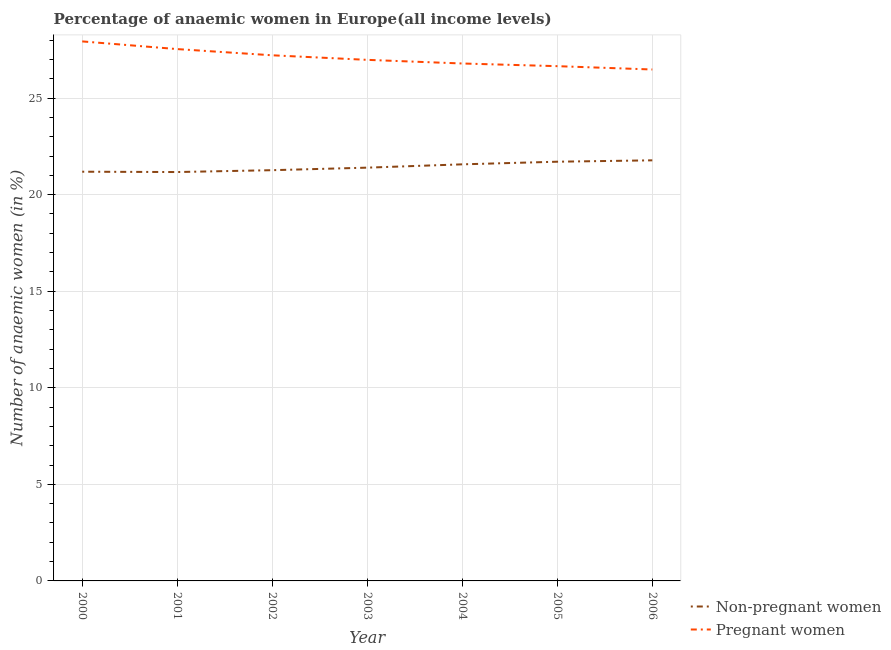How many different coloured lines are there?
Offer a terse response. 2. What is the percentage of non-pregnant anaemic women in 2002?
Make the answer very short. 21.27. Across all years, what is the maximum percentage of pregnant anaemic women?
Keep it short and to the point. 27.93. Across all years, what is the minimum percentage of pregnant anaemic women?
Keep it short and to the point. 26.48. What is the total percentage of non-pregnant anaemic women in the graph?
Make the answer very short. 150.07. What is the difference between the percentage of pregnant anaemic women in 2002 and that in 2006?
Your response must be concise. 0.74. What is the difference between the percentage of pregnant anaemic women in 2003 and the percentage of non-pregnant anaemic women in 2005?
Ensure brevity in your answer.  5.27. What is the average percentage of pregnant anaemic women per year?
Your response must be concise. 27.08. In the year 2002, what is the difference between the percentage of non-pregnant anaemic women and percentage of pregnant anaemic women?
Offer a terse response. -5.95. In how many years, is the percentage of non-pregnant anaemic women greater than 25 %?
Give a very brief answer. 0. What is the ratio of the percentage of pregnant anaemic women in 2001 to that in 2006?
Offer a very short reply. 1.04. Is the percentage of non-pregnant anaemic women in 2003 less than that in 2004?
Offer a terse response. Yes. What is the difference between the highest and the second highest percentage of non-pregnant anaemic women?
Your answer should be compact. 0.07. What is the difference between the highest and the lowest percentage of pregnant anaemic women?
Provide a short and direct response. 1.45. In how many years, is the percentage of pregnant anaemic women greater than the average percentage of pregnant anaemic women taken over all years?
Your response must be concise. 3. Is the sum of the percentage of non-pregnant anaemic women in 2000 and 2003 greater than the maximum percentage of pregnant anaemic women across all years?
Ensure brevity in your answer.  Yes. How many lines are there?
Provide a succinct answer. 2. How many years are there in the graph?
Offer a very short reply. 7. Are the values on the major ticks of Y-axis written in scientific E-notation?
Offer a terse response. No. Does the graph contain any zero values?
Your answer should be compact. No. Does the graph contain grids?
Your answer should be compact. Yes. How many legend labels are there?
Offer a terse response. 2. What is the title of the graph?
Provide a succinct answer. Percentage of anaemic women in Europe(all income levels). What is the label or title of the Y-axis?
Your answer should be compact. Number of anaemic women (in %). What is the Number of anaemic women (in %) of Non-pregnant women in 2000?
Offer a very short reply. 21.19. What is the Number of anaemic women (in %) in Pregnant women in 2000?
Keep it short and to the point. 27.93. What is the Number of anaemic women (in %) of Non-pregnant women in 2001?
Ensure brevity in your answer.  21.17. What is the Number of anaemic women (in %) in Pregnant women in 2001?
Provide a short and direct response. 27.54. What is the Number of anaemic women (in %) in Non-pregnant women in 2002?
Provide a short and direct response. 21.27. What is the Number of anaemic women (in %) in Pregnant women in 2002?
Give a very brief answer. 27.21. What is the Number of anaemic women (in %) of Non-pregnant women in 2003?
Your response must be concise. 21.4. What is the Number of anaemic women (in %) in Pregnant women in 2003?
Offer a very short reply. 26.98. What is the Number of anaemic women (in %) in Non-pregnant women in 2004?
Make the answer very short. 21.57. What is the Number of anaemic women (in %) of Pregnant women in 2004?
Your response must be concise. 26.79. What is the Number of anaemic women (in %) in Non-pregnant women in 2005?
Make the answer very short. 21.7. What is the Number of anaemic women (in %) of Pregnant women in 2005?
Keep it short and to the point. 26.65. What is the Number of anaemic women (in %) in Non-pregnant women in 2006?
Offer a terse response. 21.78. What is the Number of anaemic women (in %) in Pregnant women in 2006?
Provide a succinct answer. 26.48. Across all years, what is the maximum Number of anaemic women (in %) of Non-pregnant women?
Provide a short and direct response. 21.78. Across all years, what is the maximum Number of anaemic women (in %) of Pregnant women?
Offer a very short reply. 27.93. Across all years, what is the minimum Number of anaemic women (in %) in Non-pregnant women?
Make the answer very short. 21.17. Across all years, what is the minimum Number of anaemic women (in %) in Pregnant women?
Your answer should be compact. 26.48. What is the total Number of anaemic women (in %) of Non-pregnant women in the graph?
Provide a short and direct response. 150.07. What is the total Number of anaemic women (in %) of Pregnant women in the graph?
Provide a short and direct response. 189.58. What is the difference between the Number of anaemic women (in %) of Non-pregnant women in 2000 and that in 2001?
Offer a very short reply. 0.02. What is the difference between the Number of anaemic women (in %) of Pregnant women in 2000 and that in 2001?
Your answer should be compact. 0.4. What is the difference between the Number of anaemic women (in %) of Non-pregnant women in 2000 and that in 2002?
Provide a short and direct response. -0.08. What is the difference between the Number of anaemic women (in %) of Pregnant women in 2000 and that in 2002?
Provide a succinct answer. 0.72. What is the difference between the Number of anaemic women (in %) in Non-pregnant women in 2000 and that in 2003?
Provide a succinct answer. -0.21. What is the difference between the Number of anaemic women (in %) of Pregnant women in 2000 and that in 2003?
Offer a very short reply. 0.96. What is the difference between the Number of anaemic women (in %) of Non-pregnant women in 2000 and that in 2004?
Provide a short and direct response. -0.38. What is the difference between the Number of anaemic women (in %) in Pregnant women in 2000 and that in 2004?
Make the answer very short. 1.14. What is the difference between the Number of anaemic women (in %) of Non-pregnant women in 2000 and that in 2005?
Offer a terse response. -0.52. What is the difference between the Number of anaemic women (in %) of Pregnant women in 2000 and that in 2005?
Provide a short and direct response. 1.28. What is the difference between the Number of anaemic women (in %) of Non-pregnant women in 2000 and that in 2006?
Your answer should be very brief. -0.59. What is the difference between the Number of anaemic women (in %) in Pregnant women in 2000 and that in 2006?
Make the answer very short. 1.45. What is the difference between the Number of anaemic women (in %) of Non-pregnant women in 2001 and that in 2002?
Your answer should be very brief. -0.1. What is the difference between the Number of anaemic women (in %) in Pregnant women in 2001 and that in 2002?
Give a very brief answer. 0.32. What is the difference between the Number of anaemic women (in %) in Non-pregnant women in 2001 and that in 2003?
Offer a very short reply. -0.23. What is the difference between the Number of anaemic women (in %) in Pregnant women in 2001 and that in 2003?
Make the answer very short. 0.56. What is the difference between the Number of anaemic women (in %) in Non-pregnant women in 2001 and that in 2004?
Your answer should be very brief. -0.4. What is the difference between the Number of anaemic women (in %) in Pregnant women in 2001 and that in 2004?
Your answer should be very brief. 0.75. What is the difference between the Number of anaemic women (in %) in Non-pregnant women in 2001 and that in 2005?
Ensure brevity in your answer.  -0.53. What is the difference between the Number of anaemic women (in %) in Pregnant women in 2001 and that in 2005?
Provide a short and direct response. 0.88. What is the difference between the Number of anaemic women (in %) in Non-pregnant women in 2001 and that in 2006?
Your answer should be compact. -0.61. What is the difference between the Number of anaemic women (in %) of Pregnant women in 2001 and that in 2006?
Make the answer very short. 1.06. What is the difference between the Number of anaemic women (in %) in Non-pregnant women in 2002 and that in 2003?
Offer a terse response. -0.13. What is the difference between the Number of anaemic women (in %) in Pregnant women in 2002 and that in 2003?
Give a very brief answer. 0.24. What is the difference between the Number of anaemic women (in %) in Non-pregnant women in 2002 and that in 2004?
Ensure brevity in your answer.  -0.3. What is the difference between the Number of anaemic women (in %) in Pregnant women in 2002 and that in 2004?
Give a very brief answer. 0.42. What is the difference between the Number of anaemic women (in %) in Non-pregnant women in 2002 and that in 2005?
Provide a succinct answer. -0.44. What is the difference between the Number of anaemic women (in %) in Pregnant women in 2002 and that in 2005?
Offer a very short reply. 0.56. What is the difference between the Number of anaemic women (in %) in Non-pregnant women in 2002 and that in 2006?
Keep it short and to the point. -0.51. What is the difference between the Number of anaemic women (in %) in Pregnant women in 2002 and that in 2006?
Your answer should be compact. 0.74. What is the difference between the Number of anaemic women (in %) of Non-pregnant women in 2003 and that in 2004?
Ensure brevity in your answer.  -0.17. What is the difference between the Number of anaemic women (in %) in Pregnant women in 2003 and that in 2004?
Offer a terse response. 0.19. What is the difference between the Number of anaemic women (in %) in Non-pregnant women in 2003 and that in 2005?
Offer a terse response. -0.31. What is the difference between the Number of anaemic women (in %) in Pregnant women in 2003 and that in 2005?
Your response must be concise. 0.33. What is the difference between the Number of anaemic women (in %) of Non-pregnant women in 2003 and that in 2006?
Provide a short and direct response. -0.38. What is the difference between the Number of anaemic women (in %) in Pregnant women in 2003 and that in 2006?
Offer a very short reply. 0.5. What is the difference between the Number of anaemic women (in %) in Non-pregnant women in 2004 and that in 2005?
Offer a very short reply. -0.14. What is the difference between the Number of anaemic women (in %) of Pregnant women in 2004 and that in 2005?
Your answer should be compact. 0.14. What is the difference between the Number of anaemic women (in %) in Non-pregnant women in 2004 and that in 2006?
Make the answer very short. -0.21. What is the difference between the Number of anaemic women (in %) of Pregnant women in 2004 and that in 2006?
Keep it short and to the point. 0.31. What is the difference between the Number of anaemic women (in %) in Non-pregnant women in 2005 and that in 2006?
Offer a very short reply. -0.07. What is the difference between the Number of anaemic women (in %) in Pregnant women in 2005 and that in 2006?
Give a very brief answer. 0.17. What is the difference between the Number of anaemic women (in %) of Non-pregnant women in 2000 and the Number of anaemic women (in %) of Pregnant women in 2001?
Ensure brevity in your answer.  -6.35. What is the difference between the Number of anaemic women (in %) of Non-pregnant women in 2000 and the Number of anaemic women (in %) of Pregnant women in 2002?
Ensure brevity in your answer.  -6.03. What is the difference between the Number of anaemic women (in %) of Non-pregnant women in 2000 and the Number of anaemic women (in %) of Pregnant women in 2003?
Ensure brevity in your answer.  -5.79. What is the difference between the Number of anaemic women (in %) in Non-pregnant women in 2000 and the Number of anaemic women (in %) in Pregnant women in 2004?
Offer a terse response. -5.6. What is the difference between the Number of anaemic women (in %) in Non-pregnant women in 2000 and the Number of anaemic women (in %) in Pregnant women in 2005?
Give a very brief answer. -5.46. What is the difference between the Number of anaemic women (in %) of Non-pregnant women in 2000 and the Number of anaemic women (in %) of Pregnant women in 2006?
Give a very brief answer. -5.29. What is the difference between the Number of anaemic women (in %) of Non-pregnant women in 2001 and the Number of anaemic women (in %) of Pregnant women in 2002?
Give a very brief answer. -6.04. What is the difference between the Number of anaemic women (in %) in Non-pregnant women in 2001 and the Number of anaemic women (in %) in Pregnant women in 2003?
Make the answer very short. -5.81. What is the difference between the Number of anaemic women (in %) in Non-pregnant women in 2001 and the Number of anaemic women (in %) in Pregnant women in 2004?
Provide a succinct answer. -5.62. What is the difference between the Number of anaemic women (in %) in Non-pregnant women in 2001 and the Number of anaemic women (in %) in Pregnant women in 2005?
Provide a short and direct response. -5.48. What is the difference between the Number of anaemic women (in %) of Non-pregnant women in 2001 and the Number of anaemic women (in %) of Pregnant women in 2006?
Provide a short and direct response. -5.31. What is the difference between the Number of anaemic women (in %) in Non-pregnant women in 2002 and the Number of anaemic women (in %) in Pregnant women in 2003?
Your answer should be compact. -5.71. What is the difference between the Number of anaemic women (in %) of Non-pregnant women in 2002 and the Number of anaemic women (in %) of Pregnant women in 2004?
Give a very brief answer. -5.52. What is the difference between the Number of anaemic women (in %) in Non-pregnant women in 2002 and the Number of anaemic women (in %) in Pregnant women in 2005?
Give a very brief answer. -5.39. What is the difference between the Number of anaemic women (in %) of Non-pregnant women in 2002 and the Number of anaemic women (in %) of Pregnant women in 2006?
Make the answer very short. -5.21. What is the difference between the Number of anaemic women (in %) in Non-pregnant women in 2003 and the Number of anaemic women (in %) in Pregnant women in 2004?
Your answer should be very brief. -5.39. What is the difference between the Number of anaemic women (in %) in Non-pregnant women in 2003 and the Number of anaemic women (in %) in Pregnant women in 2005?
Provide a short and direct response. -5.25. What is the difference between the Number of anaemic women (in %) of Non-pregnant women in 2003 and the Number of anaemic women (in %) of Pregnant women in 2006?
Offer a very short reply. -5.08. What is the difference between the Number of anaemic women (in %) of Non-pregnant women in 2004 and the Number of anaemic women (in %) of Pregnant women in 2005?
Your answer should be very brief. -5.08. What is the difference between the Number of anaemic women (in %) in Non-pregnant women in 2004 and the Number of anaemic women (in %) in Pregnant women in 2006?
Offer a very short reply. -4.91. What is the difference between the Number of anaemic women (in %) in Non-pregnant women in 2005 and the Number of anaemic women (in %) in Pregnant women in 2006?
Keep it short and to the point. -4.77. What is the average Number of anaemic women (in %) in Non-pregnant women per year?
Provide a short and direct response. 21.44. What is the average Number of anaemic women (in %) of Pregnant women per year?
Offer a terse response. 27.08. In the year 2000, what is the difference between the Number of anaemic women (in %) of Non-pregnant women and Number of anaemic women (in %) of Pregnant women?
Offer a very short reply. -6.75. In the year 2001, what is the difference between the Number of anaemic women (in %) of Non-pregnant women and Number of anaemic women (in %) of Pregnant women?
Keep it short and to the point. -6.37. In the year 2002, what is the difference between the Number of anaemic women (in %) in Non-pregnant women and Number of anaemic women (in %) in Pregnant women?
Your answer should be very brief. -5.95. In the year 2003, what is the difference between the Number of anaemic women (in %) of Non-pregnant women and Number of anaemic women (in %) of Pregnant women?
Your response must be concise. -5.58. In the year 2004, what is the difference between the Number of anaemic women (in %) in Non-pregnant women and Number of anaemic women (in %) in Pregnant women?
Make the answer very short. -5.22. In the year 2005, what is the difference between the Number of anaemic women (in %) of Non-pregnant women and Number of anaemic women (in %) of Pregnant women?
Offer a very short reply. -4.95. In the year 2006, what is the difference between the Number of anaemic women (in %) of Non-pregnant women and Number of anaemic women (in %) of Pregnant women?
Provide a succinct answer. -4.7. What is the ratio of the Number of anaemic women (in %) in Pregnant women in 2000 to that in 2001?
Make the answer very short. 1.01. What is the ratio of the Number of anaemic women (in %) of Pregnant women in 2000 to that in 2002?
Provide a short and direct response. 1.03. What is the ratio of the Number of anaemic women (in %) of Non-pregnant women in 2000 to that in 2003?
Provide a succinct answer. 0.99. What is the ratio of the Number of anaemic women (in %) of Pregnant women in 2000 to that in 2003?
Ensure brevity in your answer.  1.04. What is the ratio of the Number of anaemic women (in %) in Non-pregnant women in 2000 to that in 2004?
Your answer should be very brief. 0.98. What is the ratio of the Number of anaemic women (in %) in Pregnant women in 2000 to that in 2004?
Your response must be concise. 1.04. What is the ratio of the Number of anaemic women (in %) in Non-pregnant women in 2000 to that in 2005?
Your answer should be compact. 0.98. What is the ratio of the Number of anaemic women (in %) of Pregnant women in 2000 to that in 2005?
Ensure brevity in your answer.  1.05. What is the ratio of the Number of anaemic women (in %) of Non-pregnant women in 2000 to that in 2006?
Provide a short and direct response. 0.97. What is the ratio of the Number of anaemic women (in %) in Pregnant women in 2000 to that in 2006?
Your answer should be compact. 1.05. What is the ratio of the Number of anaemic women (in %) of Pregnant women in 2001 to that in 2002?
Keep it short and to the point. 1.01. What is the ratio of the Number of anaemic women (in %) of Non-pregnant women in 2001 to that in 2003?
Your answer should be compact. 0.99. What is the ratio of the Number of anaemic women (in %) in Pregnant women in 2001 to that in 2003?
Keep it short and to the point. 1.02. What is the ratio of the Number of anaemic women (in %) of Non-pregnant women in 2001 to that in 2004?
Provide a short and direct response. 0.98. What is the ratio of the Number of anaemic women (in %) of Pregnant women in 2001 to that in 2004?
Keep it short and to the point. 1.03. What is the ratio of the Number of anaemic women (in %) of Non-pregnant women in 2001 to that in 2005?
Give a very brief answer. 0.98. What is the ratio of the Number of anaemic women (in %) in Pregnant women in 2001 to that in 2005?
Your answer should be very brief. 1.03. What is the ratio of the Number of anaemic women (in %) of Non-pregnant women in 2001 to that in 2006?
Make the answer very short. 0.97. What is the ratio of the Number of anaemic women (in %) of Pregnant women in 2001 to that in 2006?
Your response must be concise. 1.04. What is the ratio of the Number of anaemic women (in %) in Pregnant women in 2002 to that in 2003?
Your response must be concise. 1.01. What is the ratio of the Number of anaemic women (in %) of Pregnant women in 2002 to that in 2004?
Make the answer very short. 1.02. What is the ratio of the Number of anaemic women (in %) in Non-pregnant women in 2002 to that in 2005?
Give a very brief answer. 0.98. What is the ratio of the Number of anaemic women (in %) in Pregnant women in 2002 to that in 2005?
Provide a short and direct response. 1.02. What is the ratio of the Number of anaemic women (in %) of Non-pregnant women in 2002 to that in 2006?
Provide a succinct answer. 0.98. What is the ratio of the Number of anaemic women (in %) in Pregnant women in 2002 to that in 2006?
Make the answer very short. 1.03. What is the ratio of the Number of anaemic women (in %) in Non-pregnant women in 2003 to that in 2004?
Offer a very short reply. 0.99. What is the ratio of the Number of anaemic women (in %) in Non-pregnant women in 2003 to that in 2005?
Your answer should be very brief. 0.99. What is the ratio of the Number of anaemic women (in %) in Pregnant women in 2003 to that in 2005?
Your response must be concise. 1.01. What is the ratio of the Number of anaemic women (in %) of Non-pregnant women in 2003 to that in 2006?
Make the answer very short. 0.98. What is the ratio of the Number of anaemic women (in %) in Pregnant women in 2003 to that in 2006?
Make the answer very short. 1.02. What is the ratio of the Number of anaemic women (in %) of Non-pregnant women in 2004 to that in 2005?
Your answer should be very brief. 0.99. What is the ratio of the Number of anaemic women (in %) in Pregnant women in 2004 to that in 2006?
Your response must be concise. 1.01. What is the ratio of the Number of anaemic women (in %) in Non-pregnant women in 2005 to that in 2006?
Provide a short and direct response. 1. What is the ratio of the Number of anaemic women (in %) in Pregnant women in 2005 to that in 2006?
Keep it short and to the point. 1.01. What is the difference between the highest and the second highest Number of anaemic women (in %) in Non-pregnant women?
Keep it short and to the point. 0.07. What is the difference between the highest and the second highest Number of anaemic women (in %) in Pregnant women?
Offer a terse response. 0.4. What is the difference between the highest and the lowest Number of anaemic women (in %) of Non-pregnant women?
Provide a succinct answer. 0.61. What is the difference between the highest and the lowest Number of anaemic women (in %) in Pregnant women?
Make the answer very short. 1.45. 